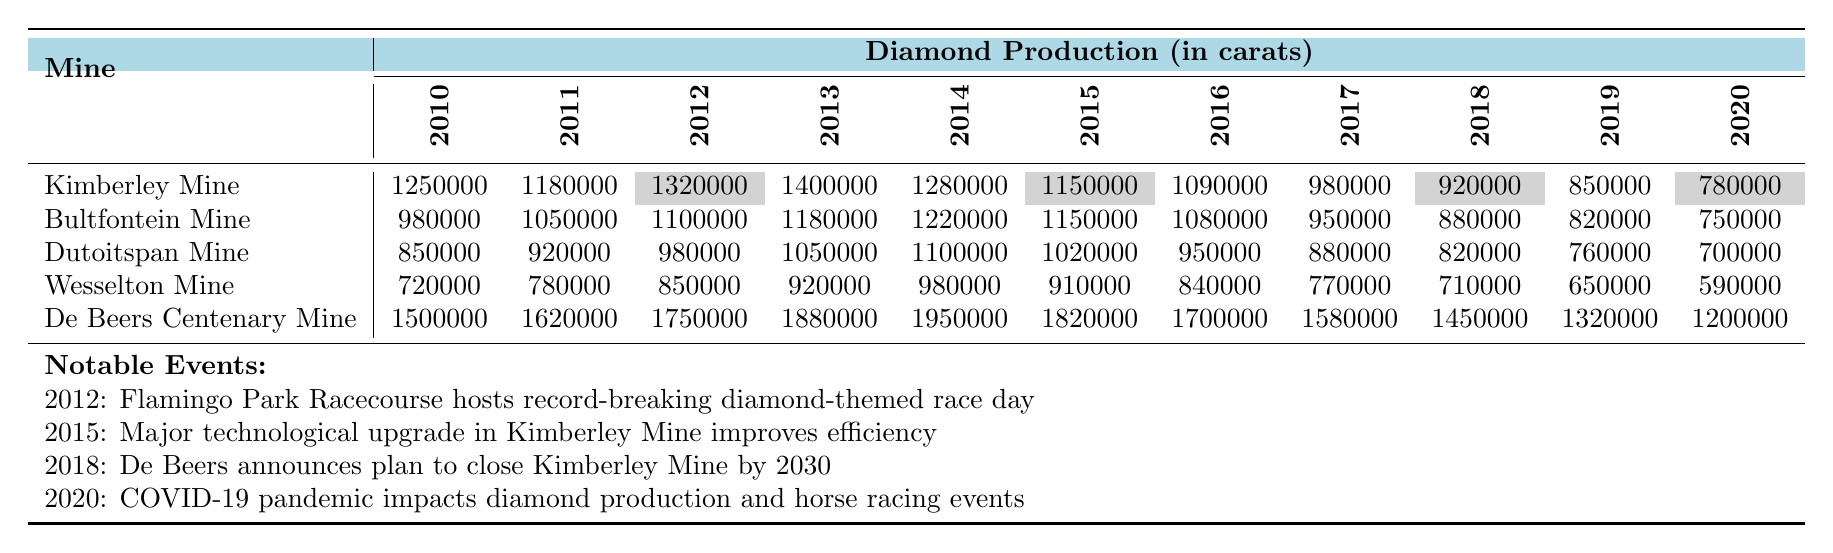What was the highest diamond production in Kimberley Mine between 2010 and 2020? The highest production value for Kimberley Mine can be found in the table, which shows 1,400,000 carats in the year 2013.
Answer: 1,400,000 carats Which mine had the lowest diamond production in 2020? By checking the figures for 2020 in the table, the production values show that Wesselton Mine had the lowest production of 590,000 carats.
Answer: Wesselton Mine What is the total diamond production for De Beers Centenary Mine from 2010 to 2020? To calculate the total production for De Beers Centenary Mine, we sum the annual production values: 1,500,000 + 1,620,000 + 1,750,000 + 1,880,000 + 1,950,000 + 1,820,000 + 1,700,000 + 1,580,000 + 1,450,000 + 1,320,000 + 1,200,000 = 18,570,000 carats.
Answer: 18,570,000 carats Did the production of Bultfontein Mine increase or decrease from 2014 to 2019? Comparing the production in 2014, which was 1,220,000 carats, with the production in 2019, which was 820,000 carats, we see a decrease in output.
Answer: Decrease What was the production decrease from 2012 to 2013 for Dutoitspan Mine? The production for Dutoitspan Mine in 2012 was 980,000 carats and in 2013 it was 1,050,000 carats. The change from 980,000 to 1,050,000 represents an increase, not a decrease, therefore the production did not decrease.
Answer: No decrease How did the production trend change for Kimberley Mine from 2010 to 2016? The production for Kimberley Mine started at 1,250,000 carats in 2010 and decreased to 1,090,000 carats in 2016. The values show a clear downward trend over this period.
Answer: Downward trend What is the average production of Wesselton Mine from 2010 to 2020? To find the average production of Wesselton Mine, we sum the yearly productions: 720,000 + 780,000 + 850,000 + 920,000 + 980,000 + 910,000 + 840,000 + 770,000 + 710,000 + 650,000 + 590,000 = 8,150,000 carats. We then divide by the number of years (11), resulting in an average of about 741,818 carats.
Answer: 741,818 carats In which year did De Beers Centenary Mine reach its peak production? By observing the production values, the peak production of De Beers Centenary Mine was 1,950,000 carats, recorded in 2014.
Answer: 2014 What was the percentage decrease in production for Dutoitspan Mine from 2010 to 2020? The production in 2010 was 850,000 carats and in 2020 was 700,000 carats. The decrease is 850,000 - 700,000 = 150,000 carats. To find the percentage decrease, we divide 150,000 by the original production of 850,000, resulting in (150,000 / 850,000) * 100 ≈ 17.65%.
Answer: Approximately 17.65% Which mine consistently produced more than 1 million carats from 2010 to 2020? By checking the values for each year, De Beers Centenary Mine consistently produced over 1 million carats every year from 2010 to 2020, while no other mine maintained such production levels throughout the same period.
Answer: De Beers Centenary Mine 